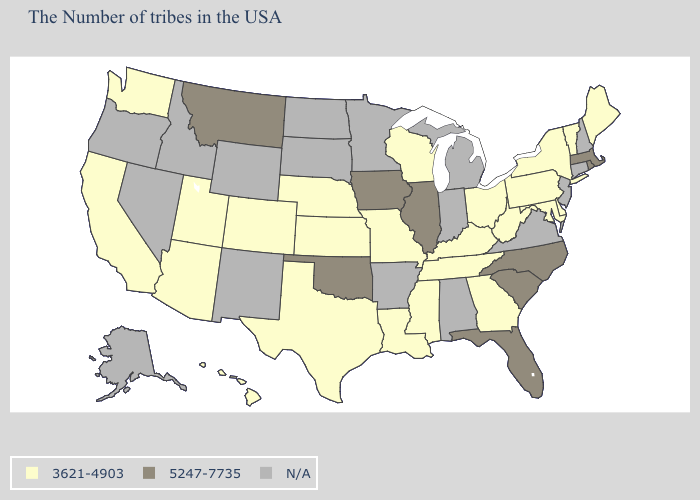Name the states that have a value in the range 5247-7735?
Give a very brief answer. Massachusetts, Rhode Island, North Carolina, South Carolina, Florida, Illinois, Iowa, Oklahoma, Montana. Name the states that have a value in the range 3621-4903?
Quick response, please. Maine, Vermont, New York, Delaware, Maryland, Pennsylvania, West Virginia, Ohio, Georgia, Kentucky, Tennessee, Wisconsin, Mississippi, Louisiana, Missouri, Kansas, Nebraska, Texas, Colorado, Utah, Arizona, California, Washington, Hawaii. Among the states that border North Carolina , which have the highest value?
Keep it brief. South Carolina. What is the value of Idaho?
Be succinct. N/A. Which states hav the highest value in the Northeast?
Answer briefly. Massachusetts, Rhode Island. Which states have the lowest value in the South?
Quick response, please. Delaware, Maryland, West Virginia, Georgia, Kentucky, Tennessee, Mississippi, Louisiana, Texas. Name the states that have a value in the range 5247-7735?
Give a very brief answer. Massachusetts, Rhode Island, North Carolina, South Carolina, Florida, Illinois, Iowa, Oklahoma, Montana. What is the highest value in the USA?
Give a very brief answer. 5247-7735. Does the first symbol in the legend represent the smallest category?
Short answer required. Yes. Does Wisconsin have the lowest value in the USA?
Be succinct. Yes. Name the states that have a value in the range N/A?
Keep it brief. New Hampshire, Connecticut, New Jersey, Virginia, Michigan, Indiana, Alabama, Arkansas, Minnesota, South Dakota, North Dakota, Wyoming, New Mexico, Idaho, Nevada, Oregon, Alaska. Does the first symbol in the legend represent the smallest category?
Quick response, please. Yes. What is the lowest value in states that border Colorado?
Keep it brief. 3621-4903. 